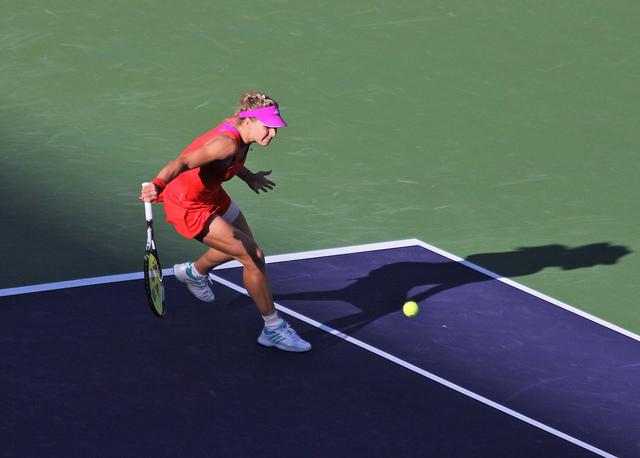What brand of shoes is she wearing?
Write a very short answer. Adidas. What is on the court to the right of the player?
Keep it brief. Tennis ball. What is the woman holding?
Give a very brief answer. Tennis racket. What color is the visor?
Write a very short answer. Pink. 